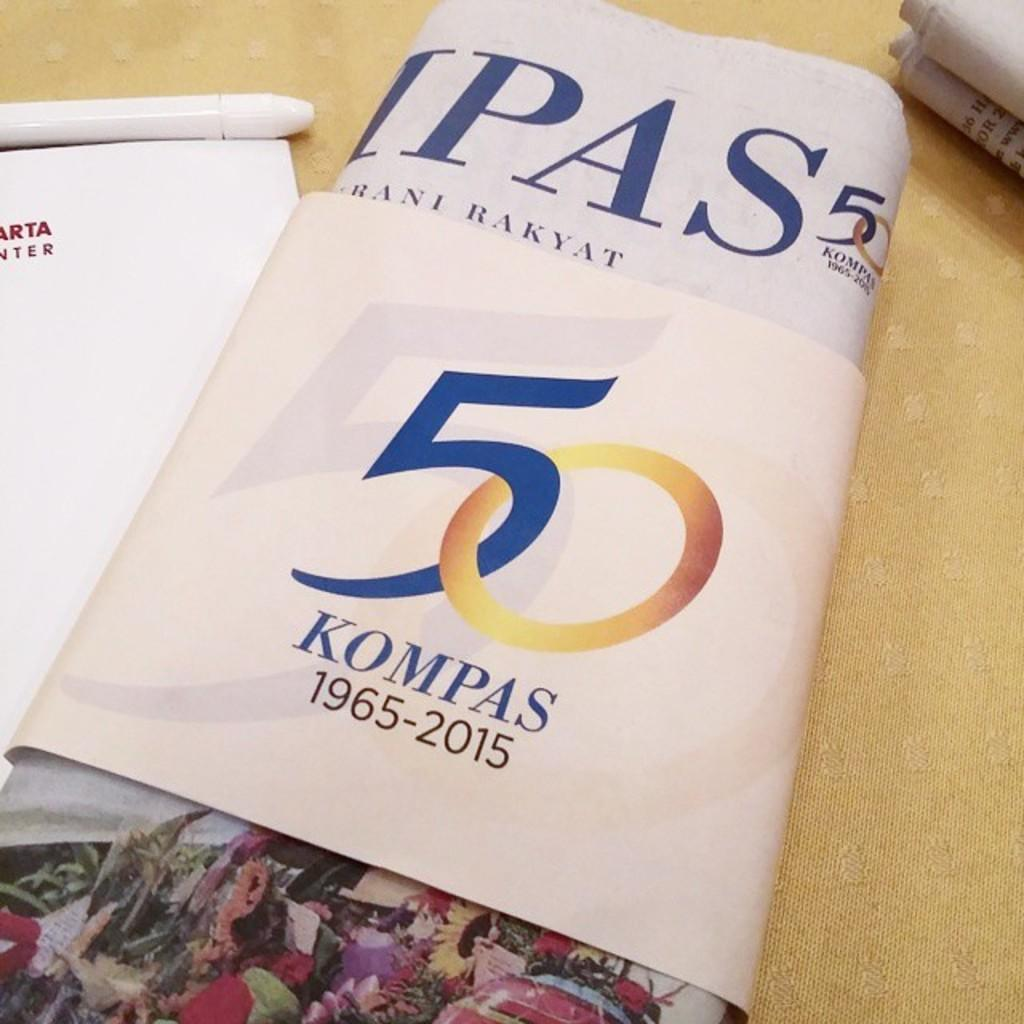Provide a one-sentence caption for the provided image. Pictured is a 50 year celebration, 1965-2015, notice titles Kompas. 